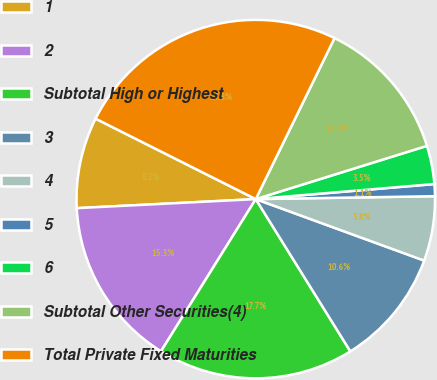Convert chart to OTSL. <chart><loc_0><loc_0><loc_500><loc_500><pie_chart><fcel>1<fcel>2<fcel>Subtotal High or Highest<fcel>3<fcel>4<fcel>5<fcel>6<fcel>Subtotal Other Securities(4)<fcel>Total Private Fixed Maturities<nl><fcel>8.21%<fcel>15.33%<fcel>17.71%<fcel>10.58%<fcel>5.83%<fcel>1.08%<fcel>3.46%<fcel>12.96%<fcel>24.83%<nl></chart> 